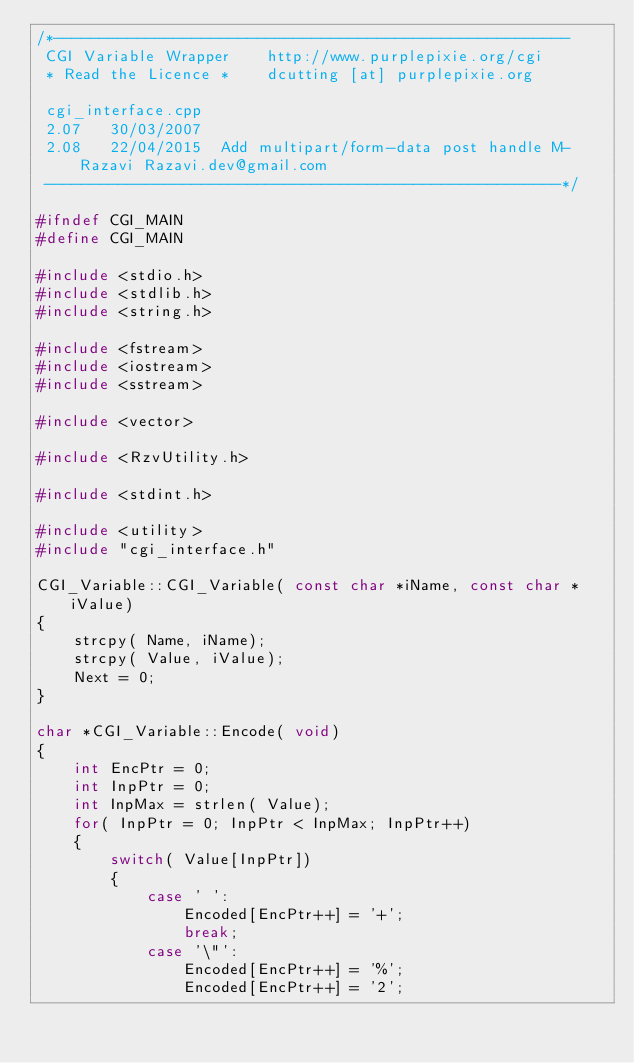<code> <loc_0><loc_0><loc_500><loc_500><_C++_>/*--------------------------------------------------------
 CGI Variable Wrapper    http://www.purplepixie.org/cgi
 * Read the Licence *    dcutting [at] purplepixie.org

 cgi_interface.cpp       
 2.07	30/03/2007	
 2.08 	22/04/2015	Add multipart/form-data post handle M-Razavi Razavi.dev@gmail.com 
 --------------------------------------------------------*/

#ifndef CGI_MAIN
#define CGI_MAIN

#include <stdio.h>
#include <stdlib.h>
#include <string.h>

#include <fstream>
#include <iostream>
#include <sstream>

#include <vector>

#include <RzvUtility.h>

#include <stdint.h>

#include <utility>
#include "cgi_interface.h"

CGI_Variable::CGI_Variable( const char *iName, const char *iValue)
{
	strcpy( Name, iName);
	strcpy( Value, iValue);
	Next = 0;
}

char *CGI_Variable::Encode( void)
{
	int EncPtr = 0;
	int InpPtr = 0;
	int InpMax = strlen( Value);
	for( InpPtr = 0; InpPtr < InpMax; InpPtr++)
	{
		switch( Value[InpPtr])
		{
			case ' ':
				Encoded[EncPtr++] = '+';
				break;
			case '\"':
				Encoded[EncPtr++] = '%';
				Encoded[EncPtr++] = '2';</code> 